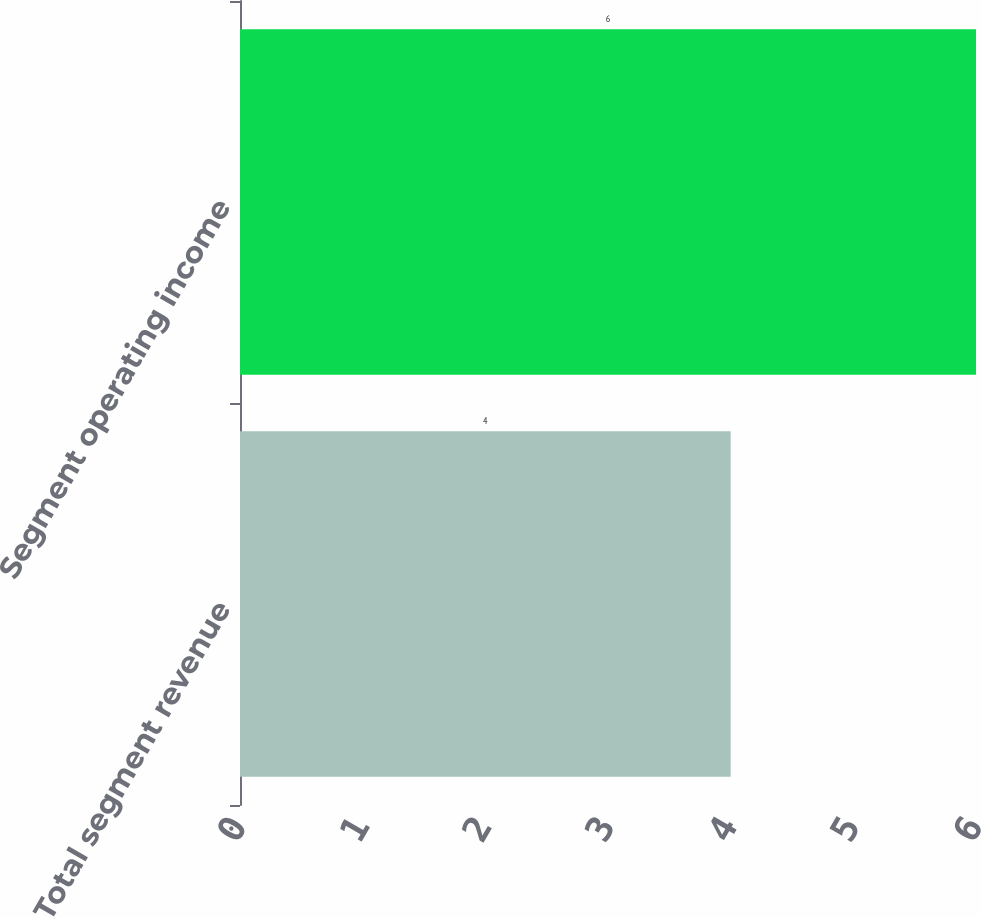Convert chart. <chart><loc_0><loc_0><loc_500><loc_500><bar_chart><fcel>Total segment revenue<fcel>Segment operating income<nl><fcel>4<fcel>6<nl></chart> 